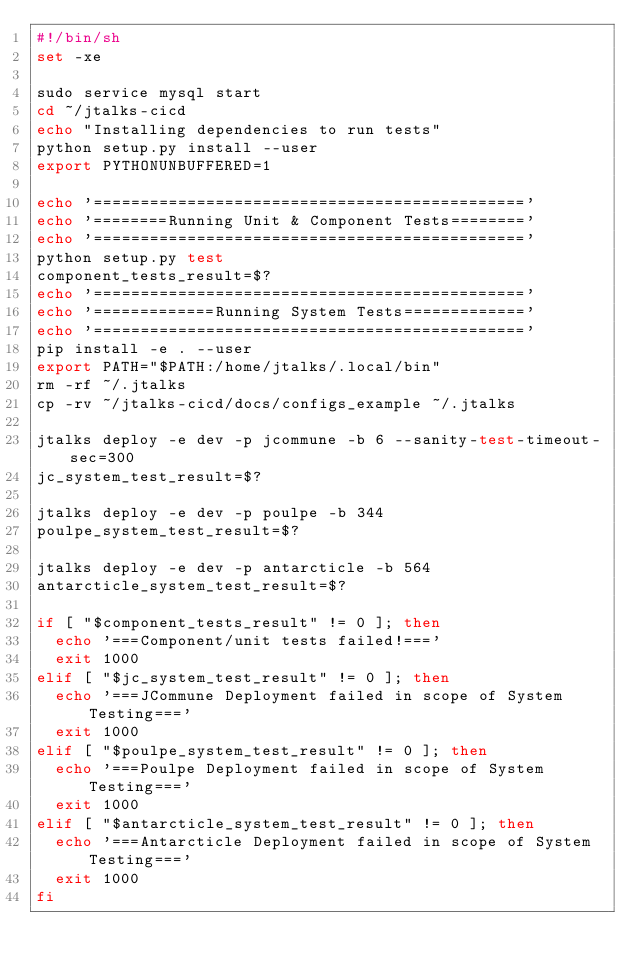<code> <loc_0><loc_0><loc_500><loc_500><_Bash_>#!/bin/sh
set -xe

sudo service mysql start
cd ~/jtalks-cicd
echo "Installing dependencies to run tests"
python setup.py install --user
export PYTHONUNBUFFERED=1

echo '=============================================='
echo '========Running Unit & Component Tests========'
echo '=============================================='
python setup.py test
component_tests_result=$?
echo '=============================================='
echo '=============Running System Tests============='
echo '=============================================='
pip install -e . --user
export PATH="$PATH:/home/jtalks/.local/bin"
rm -rf ~/.jtalks
cp -rv ~/jtalks-cicd/docs/configs_example ~/.jtalks

jtalks deploy -e dev -p jcommune -b 6 --sanity-test-timeout-sec=300
jc_system_test_result=$?

jtalks deploy -e dev -p poulpe -b 344
poulpe_system_test_result=$?

jtalks deploy -e dev -p antarcticle -b 564
antarcticle_system_test_result=$?

if [ "$component_tests_result" != 0 ]; then
  echo '===Component/unit tests failed!==='
  exit 1000
elif [ "$jc_system_test_result" != 0 ]; then
  echo '===JCommune Deployment failed in scope of System Testing==='
  exit 1000
elif [ "$poulpe_system_test_result" != 0 ]; then
  echo '===Poulpe Deployment failed in scope of System Testing==='
  exit 1000
elif [ "$antarcticle_system_test_result" != 0 ]; then
  echo '===Antarcticle Deployment failed in scope of System Testing==='
  exit 1000
fi
</code> 